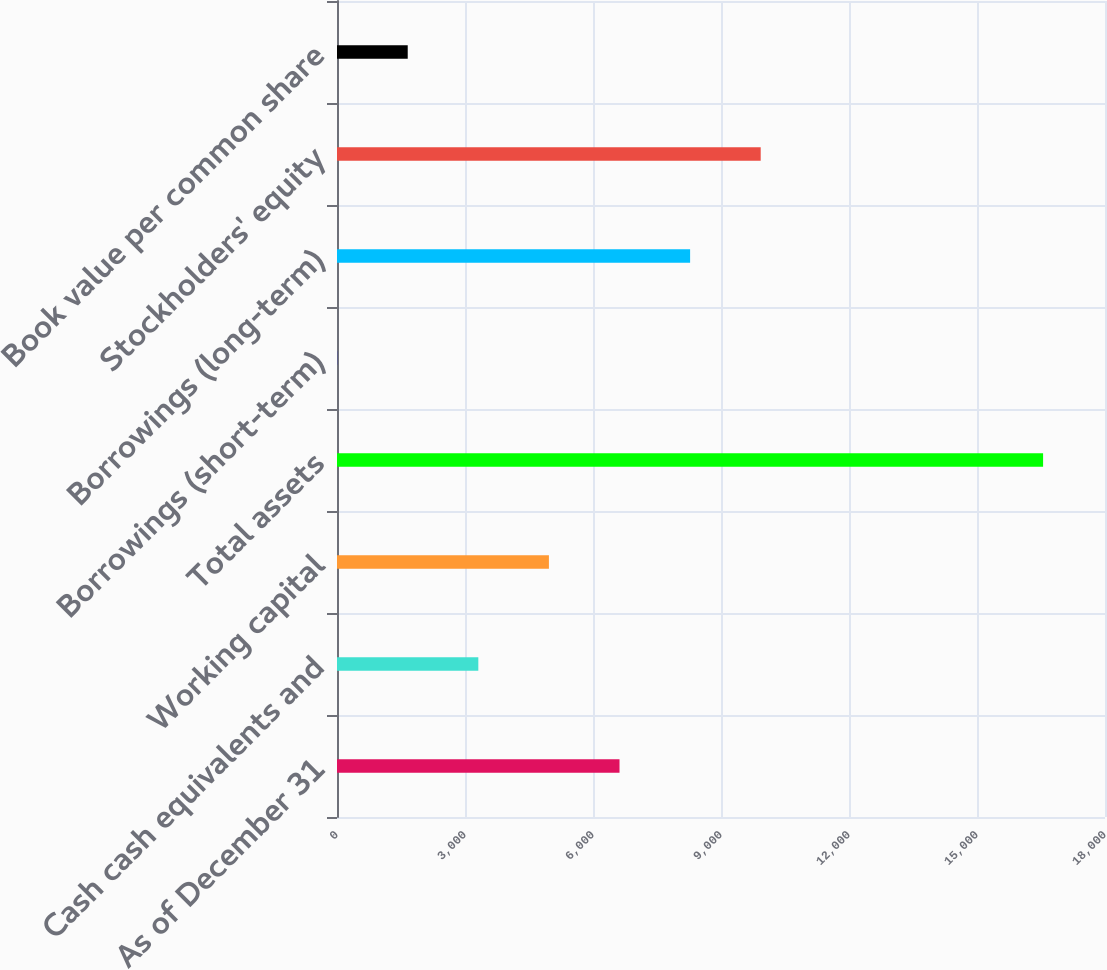Convert chart to OTSL. <chart><loc_0><loc_0><loc_500><loc_500><bar_chart><fcel>As of December 31<fcel>Cash cash equivalents and<fcel>Working capital<fcel>Total assets<fcel>Borrowings (short-term)<fcel>Borrowings (long-term)<fcel>Stockholders' equity<fcel>Book value per common share<nl><fcel>6621.4<fcel>3312.2<fcel>4966.8<fcel>16549<fcel>3<fcel>8276<fcel>9930.6<fcel>1657.6<nl></chart> 